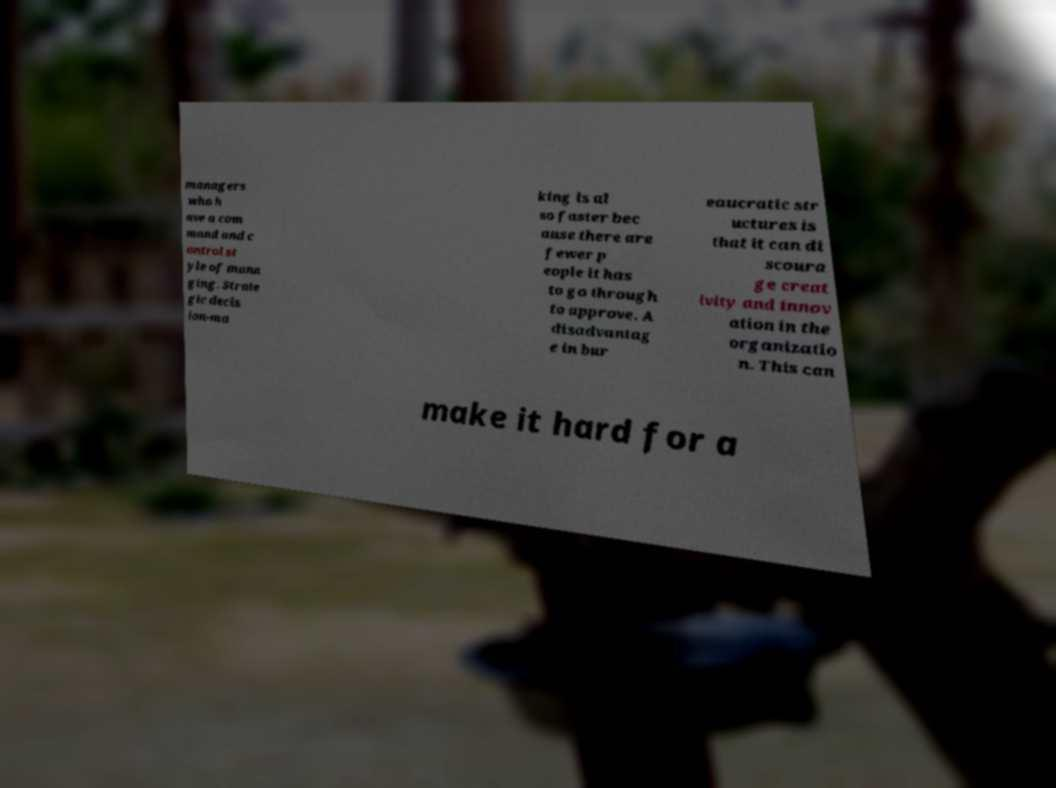Please identify and transcribe the text found in this image. managers who h ave a com mand and c ontrol st yle of mana ging. Strate gic decis ion-ma king is al so faster bec ause there are fewer p eople it has to go through to approve. A disadvantag e in bur eaucratic str uctures is that it can di scoura ge creat ivity and innov ation in the organizatio n. This can make it hard for a 